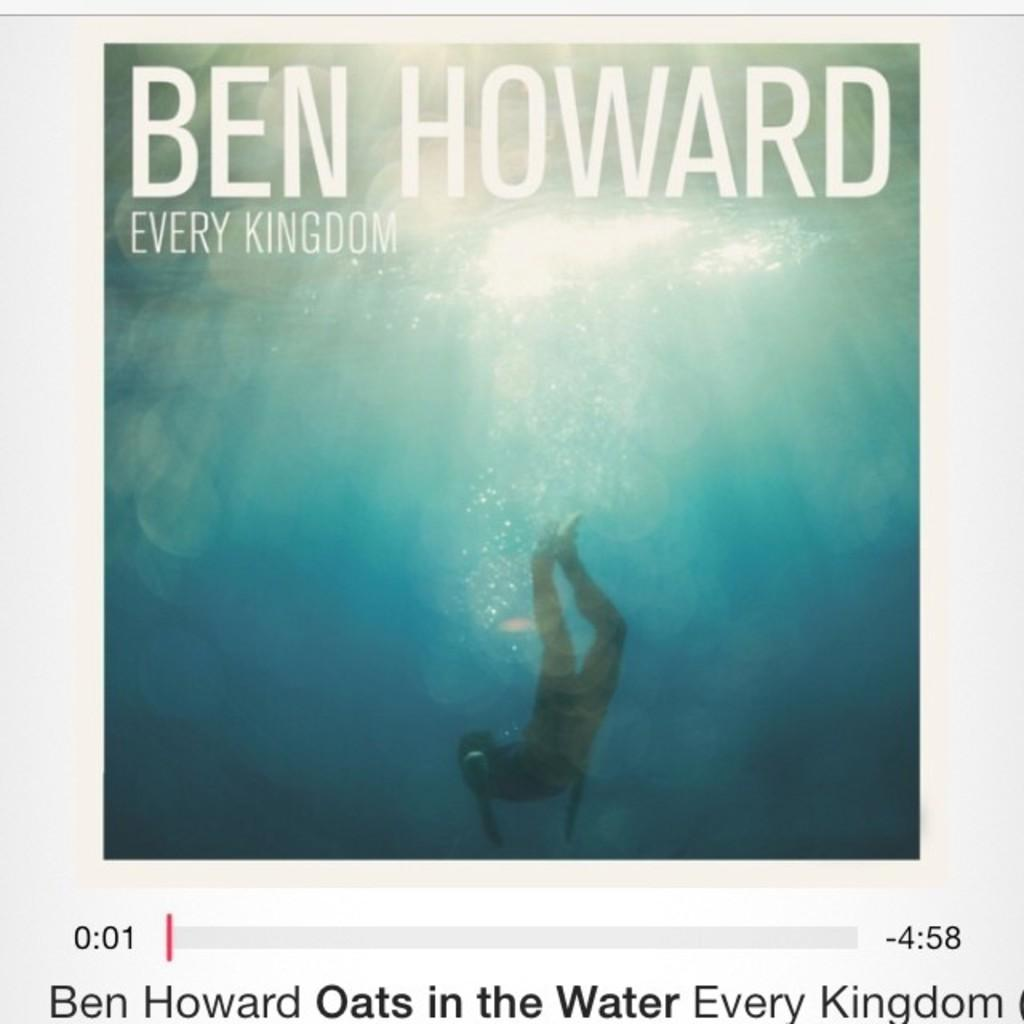<image>
Render a clear and concise summary of the photo. CD cover of artist called Ben Howard Every kingdom 